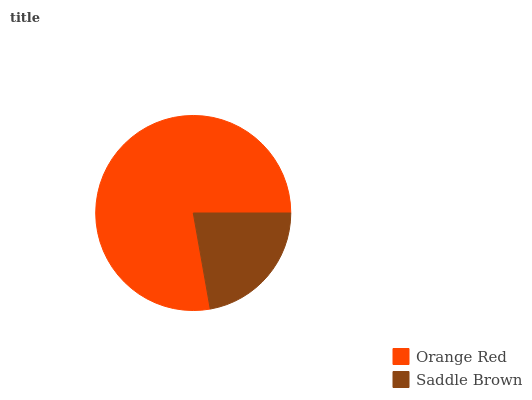Is Saddle Brown the minimum?
Answer yes or no. Yes. Is Orange Red the maximum?
Answer yes or no. Yes. Is Saddle Brown the maximum?
Answer yes or no. No. Is Orange Red greater than Saddle Brown?
Answer yes or no. Yes. Is Saddle Brown less than Orange Red?
Answer yes or no. Yes. Is Saddle Brown greater than Orange Red?
Answer yes or no. No. Is Orange Red less than Saddle Brown?
Answer yes or no. No. Is Orange Red the high median?
Answer yes or no. Yes. Is Saddle Brown the low median?
Answer yes or no. Yes. Is Saddle Brown the high median?
Answer yes or no. No. Is Orange Red the low median?
Answer yes or no. No. 